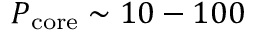<formula> <loc_0><loc_0><loc_500><loc_500>P _ { c o r e } \sim 1 0 - 1 0 0</formula> 